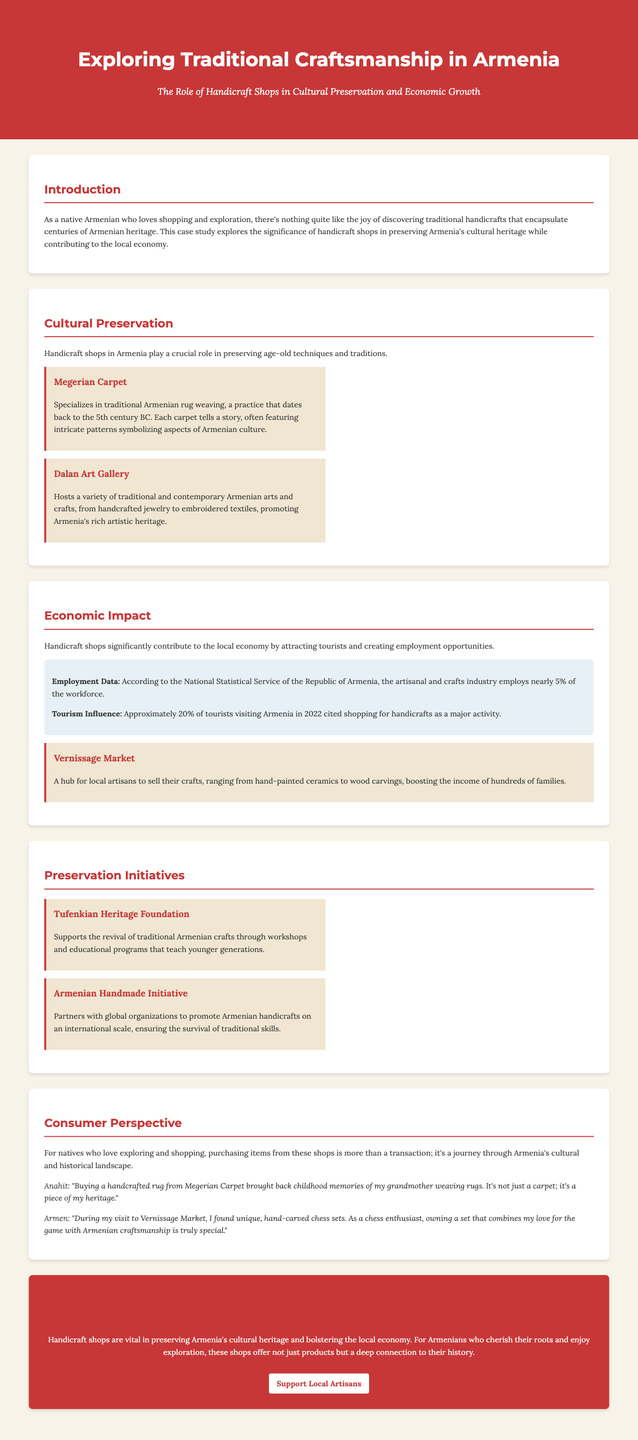What are the names of two handicraft shops mentioned in the document? The document specifies two handicraft shops: Megerian Carpet and Dalan Art Gallery.
Answer: Megerian Carpet, Dalan Art Gallery What percentage of the workforce is employed in the artisanal and crafts industry? The document states that nearly 5% of the workforce is employed in the artisanal and crafts industry.
Answer: 5% What was a major activity for 20% of tourists visiting Armenia in 2022? According to the document, shopping for handicrafts was cited as a major activity for approximately 20% of tourists.
Answer: Shopping for handicrafts Which foundation supports the revival of traditional Armenian crafts? The Tufenkian Heritage Foundation is mentioned as supporting the revival of traditional Armenian crafts in the document.
Answer: Tufenkian Heritage Foundation What type of products can be found at the Vernissage Market? The document lists hand-painted ceramics and wood carvings as examples of products found at Vernissage Market.
Answer: Hand-painted ceramics, wood carvings How do consumers view their purchases from handicraft shops? The document indicates that for natives, purchasing from these shops represents a journey through Armenia's cultural and historical landscape.
Answer: A journey through cultural and historical landscape What is the overall conclusion regarding handicraft shops in Armenia? The conclusion emphasizes that handicraft shops are vital in preserving cultural heritage and bolstering the local economy.
Answer: Vital in preserving cultural heritage and bolstering the local economy What did Anahit buy from Megerian Carpet? Anahit mentions buying a handcrafted rug from Megerian Carpet in her customer story.
Answer: A handcrafted rug What type of initiative is the Armenian Handmade Initiative? The Armenian Handmade Initiative is described as partnering with global organizations to promote Armenian handicrafts.
Answer: A promotion initiative 